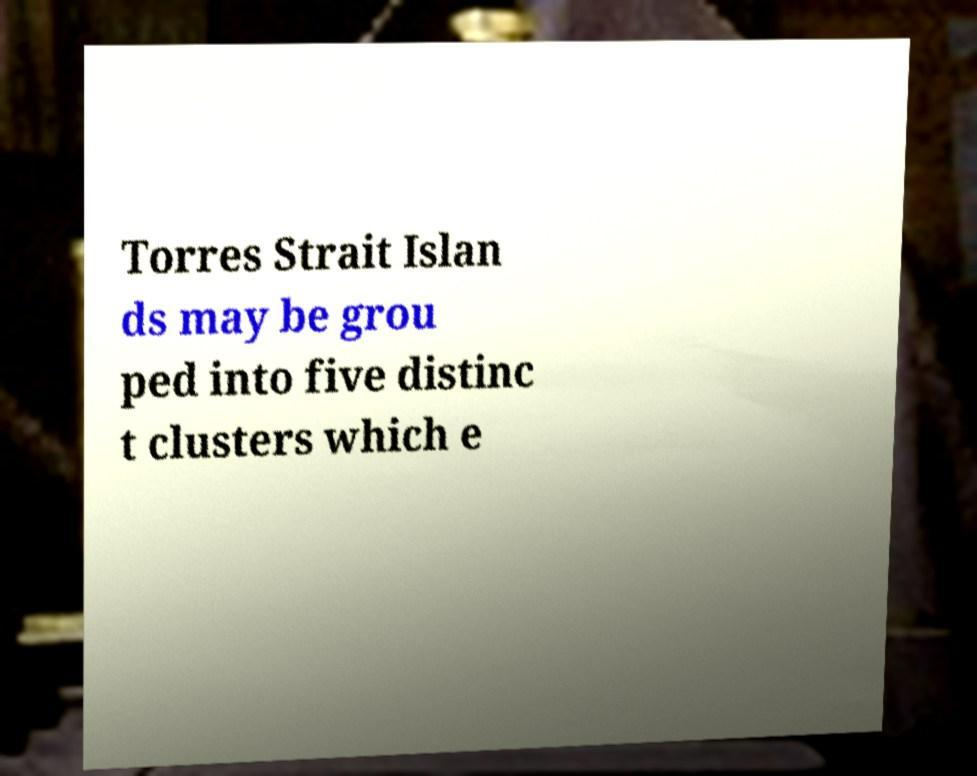Please read and relay the text visible in this image. What does it say? Torres Strait Islan ds may be grou ped into five distinc t clusters which e 